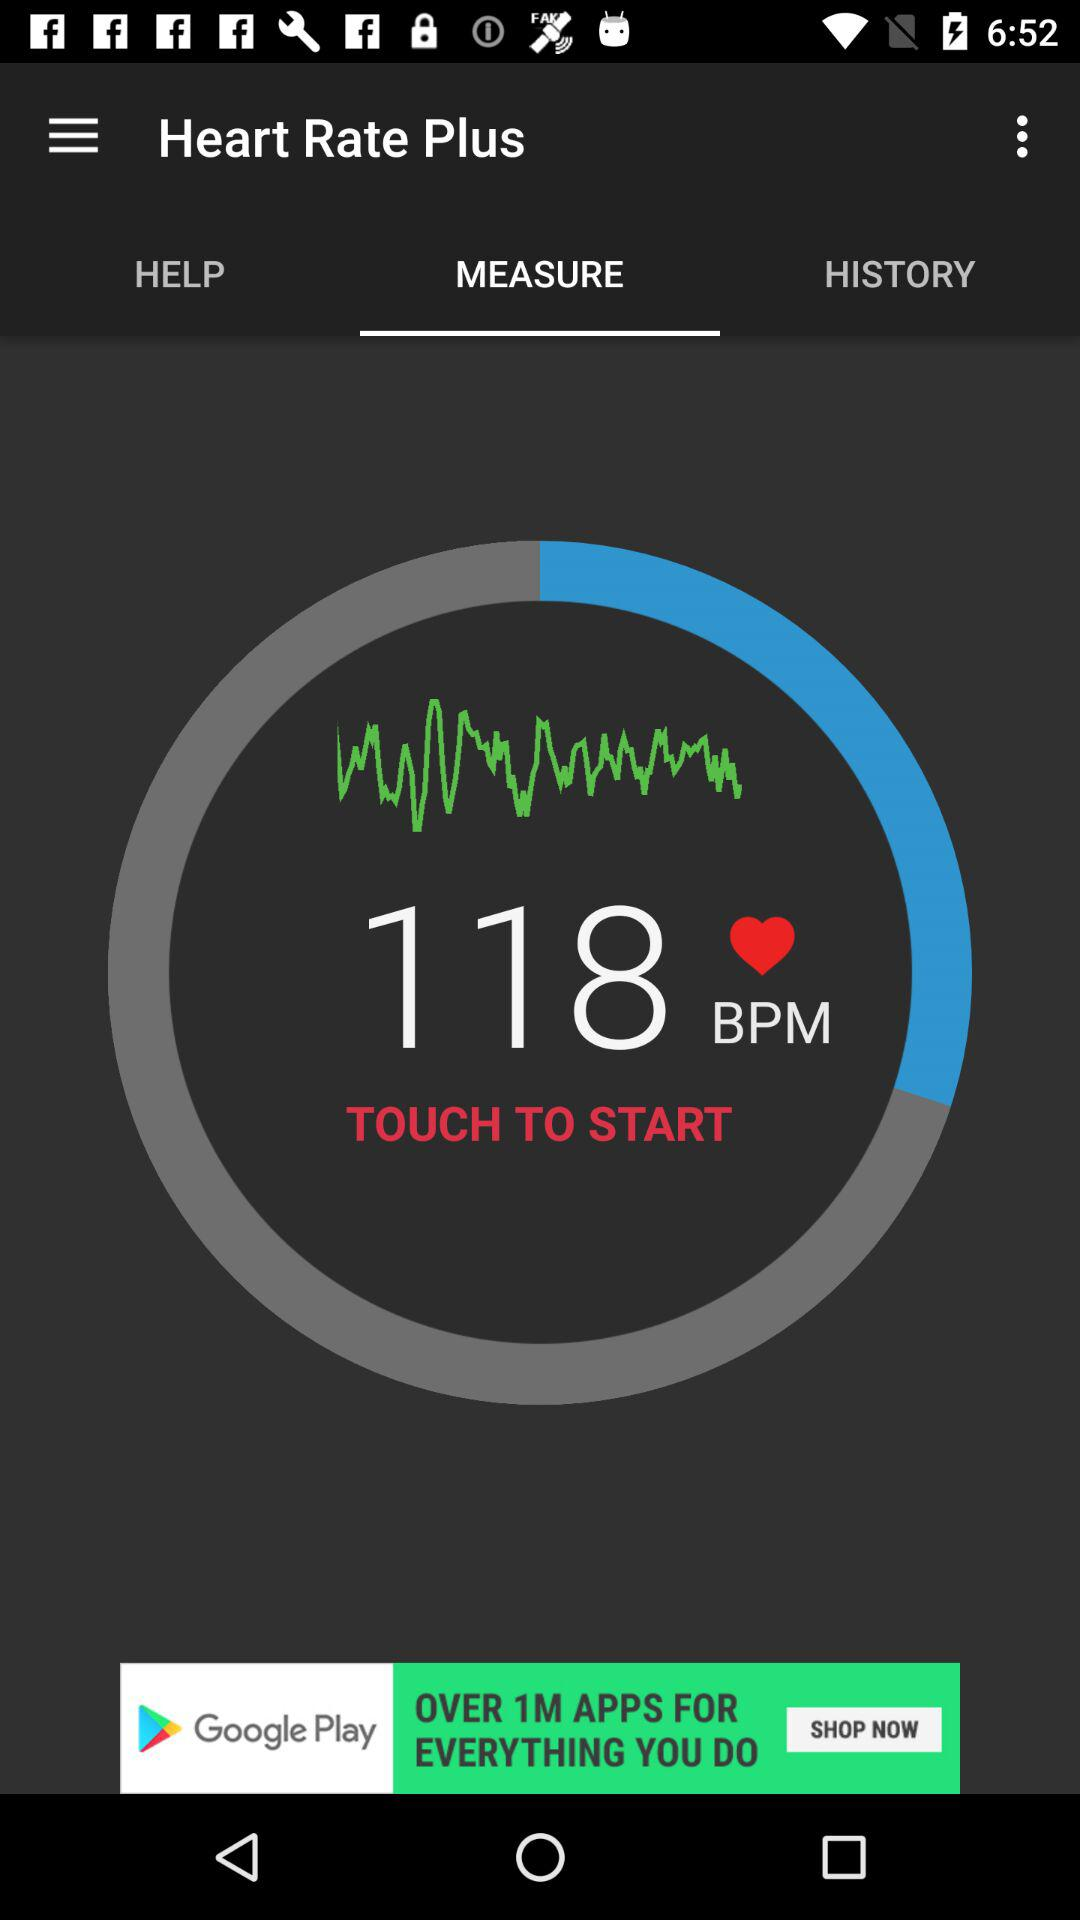What is the name of the application? The name of the application is "Heart Rate Plus". 